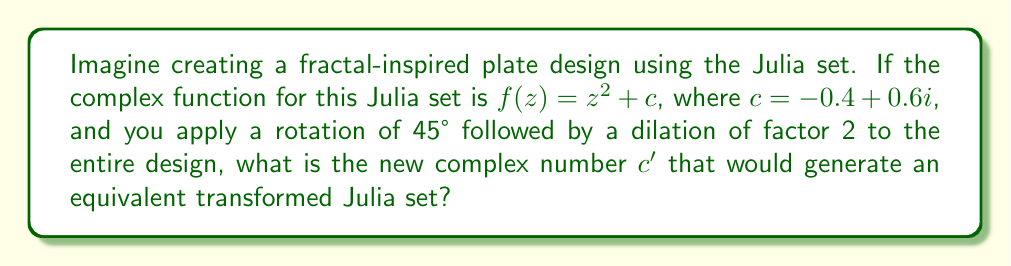Could you help me with this problem? To solve this problem, we'll follow these steps:

1) First, let's recall that a rotation by $\theta$ radians followed by a dilation of factor $r$ can be represented by multiplication with the complex number $re^{i\theta}$.

2) In this case, we have a rotation of 45° (which is $\pi/4$ radians) and a dilation of factor 2. So, our transformation is represented by:

   $2e^{i\pi/4} = 2(\cos(\pi/4) + i\sin(\pi/4)) = \sqrt{2} + i\sqrt{2}$

3) To find the new $c'$, we need to apply this transformation to the original $c$:

   $c' = (\sqrt{2} + i\sqrt{2})(-0.4 + 0.6i)$

4) Let's multiply these complex numbers:
   
   $(\sqrt{2} + i\sqrt{2})(-0.4 + 0.6i)$
   $= -0.4\sqrt{2} - 0.4i\sqrt{2} + 0.6i\sqrt{2} + 0.6\cdot 2i^2$
   $= -0.4\sqrt{2} + 0.2i\sqrt{2} - 1.2$
   $= -0.4\sqrt{2} - 1.2 + 0.2i\sqrt{2}$

5) Simplifying:
   
   $c' \approx -1.77 + 0.28i$

This new complex number $c'$ will generate a Julia set that looks like the original one rotated by 45° and dilated by a factor of 2.
Answer: $c' \approx -1.77 + 0.28i$ 